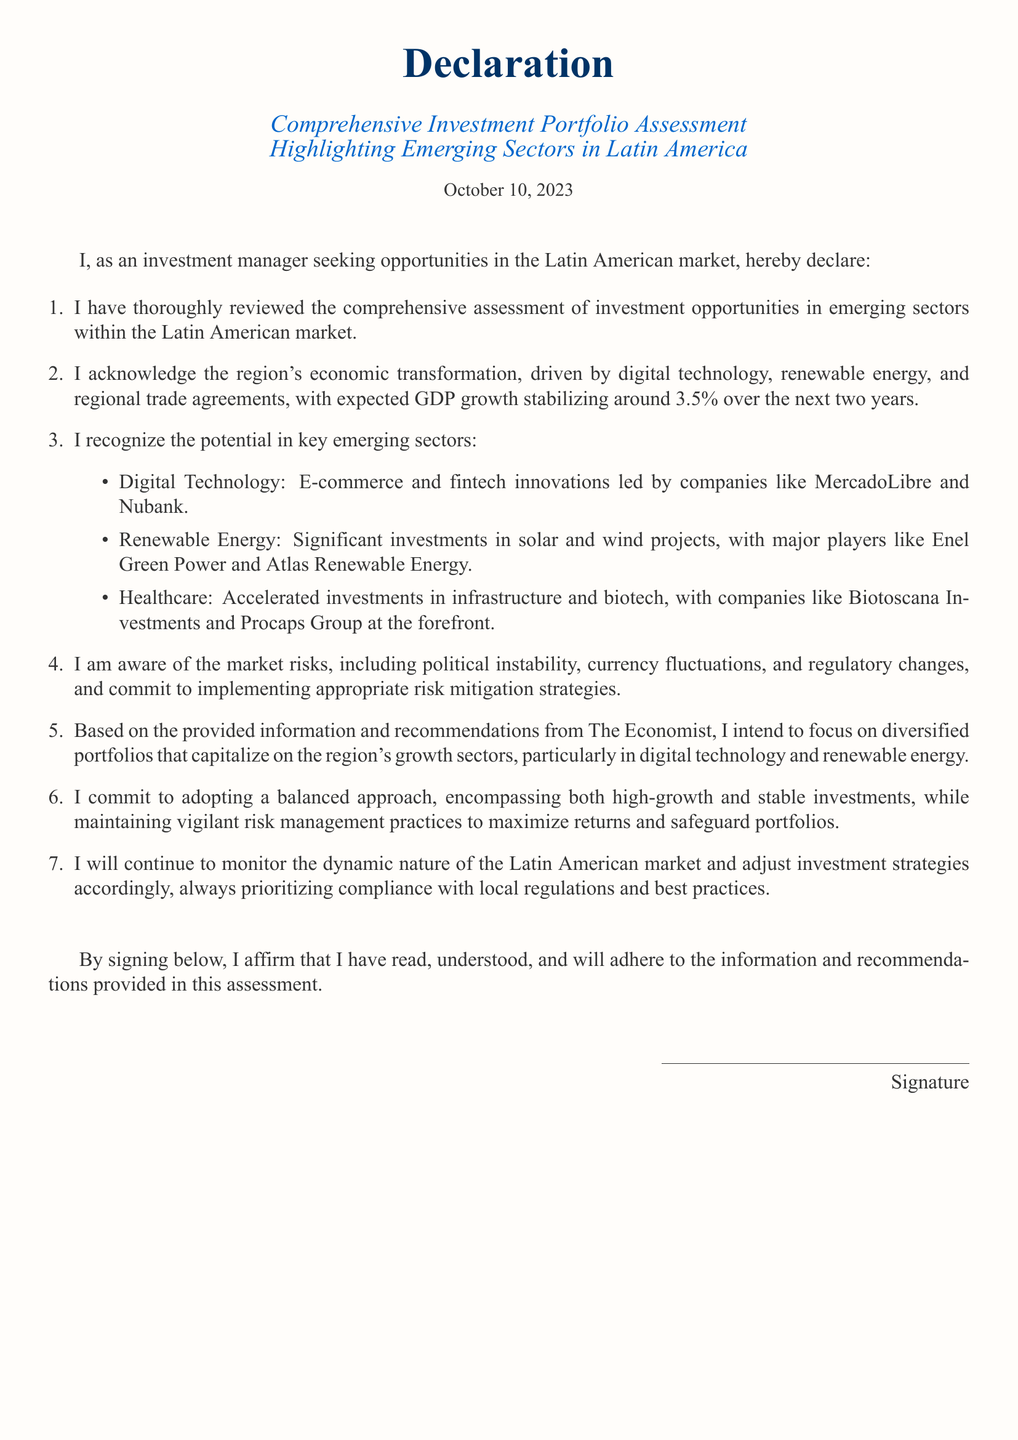What is the date of the declaration? The date is noted at the end of the title section as "October 10, 2023."
Answer: October 10, 2023 What is the expected GDP growth for Latin America over the next two years? The expected GDP growth is specified in the document as stabilizing around 3.5%.
Answer: 3.5% Who are key players in the digital technology sector mentioned? The document lists "MercadoLibre" and "Nubank" as key players in the digital technology sector.
Answer: MercadoLibre and Nubank What emerging sector is associated with Enel Green Power? Enel Green Power is associated with renewable energy sector as indicated in the document.
Answer: Renewable Energy What commitments does the investment manager make regarding risk management? The declaration mentions a commitment to "implementing appropriate risk mitigation strategies."
Answer: Risk mitigation strategies How does the investment manager intend to approach investment portfolios? The manager commits to focusing on "diversified portfolios."
Answer: Diversified portfolios Which company is noted for accelerated investments in healthcare? The document mentions "Biotoscana Investments" as a company at the forefront of healthcare investments.
Answer: Biotoscana Investments What type of document is this? The document is a declaration related to investment portfolio assessment.
Answer: Declaration 